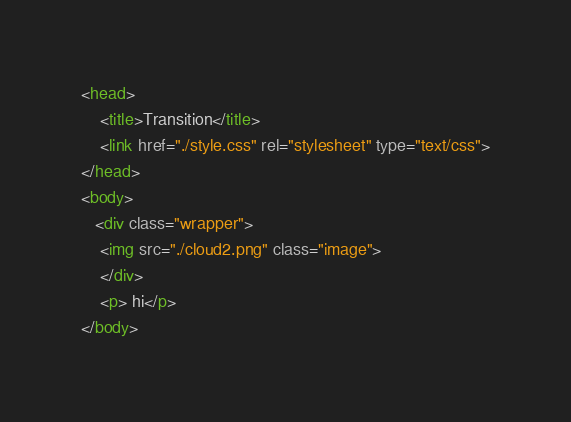Convert code to text. <code><loc_0><loc_0><loc_500><loc_500><_HTML_><head>
	<title>Transition</title>
	<link href="./style.css" rel="stylesheet" type="text/css">
</head>
<body>
   <div class="wrapper">
	<img src="./cloud2.png" class="image">
	</div>
	<p> hi</p>
</body></code> 